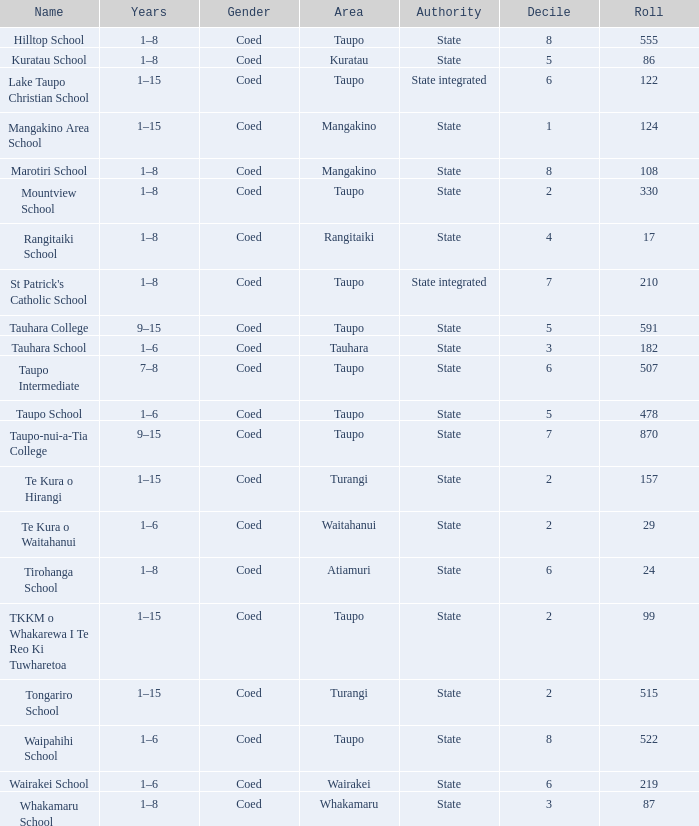In which location is the state-governed school that has a student body exceeding 157 individuals? Taupo, Taupo, Taupo, Tauhara, Taupo, Taupo, Taupo, Turangi, Taupo, Wairakei. 